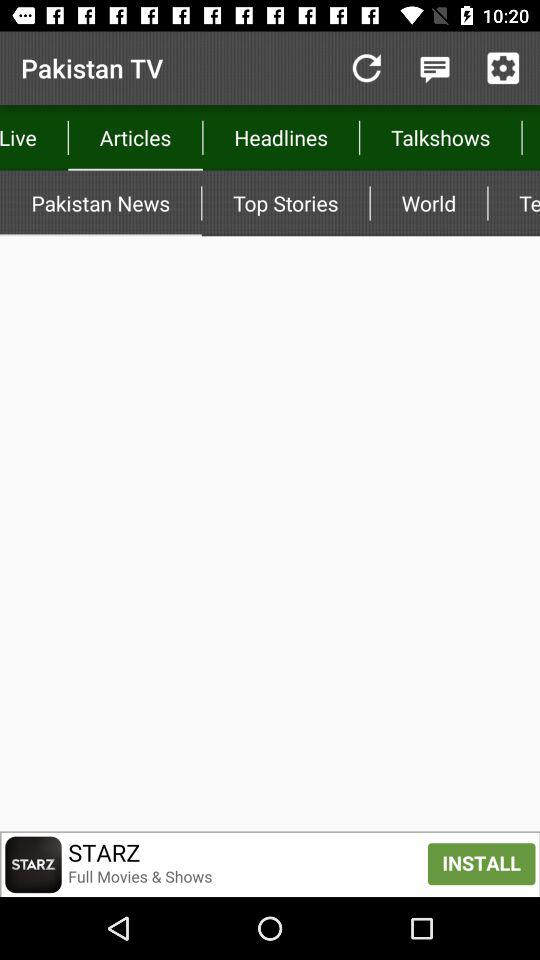Which option is selected in "Articles"? The selected option is "Pakistan News". 